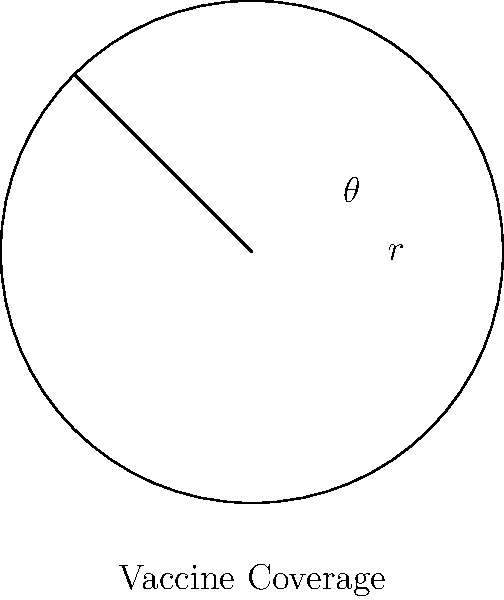A circular region represents the population of a city. The radius of the circle is 5 km, symbolizing 100% vaccine coverage. If the actual vaccine coverage is represented by a sector with a central angle of $\frac{3\pi}{4}$ radians, what percentage of the population has been vaccinated? Round your answer to the nearest whole number. To solve this problem, we need to follow these steps:

1) The area of a circle is given by the formula $A = \pi r^2$.

2) The area of a sector is given by $A_{sector} = \frac{1}{2} r^2 \theta$, where $\theta$ is the central angle in radians.

3) In this case, $r = 5$ km and $\theta = \frac{3\pi}{4}$ radians.

4) Let's calculate the area of the whole circle:
   $A_{circle} = \pi r^2 = \pi (5)^2 = 25\pi$ sq km

5) Now, let's calculate the area of the sector:
   $A_{sector} = \frac{1}{2} r^2 \theta = \frac{1}{2} (5)^2 \frac{3\pi}{4} = \frac{75\pi}{8}$ sq km

6) The percentage of the population vaccinated is the ratio of these areas:
   $\text{Percentage} = \frac{A_{sector}}{A_{circle}} \times 100\% = \frac{\frac{75\pi}{8}}{25\pi} \times 100\% = \frac{75}{200} \times 100\% = 37.5\%$

7) Rounding to the nearest whole number, we get 38%.
Answer: 38% 